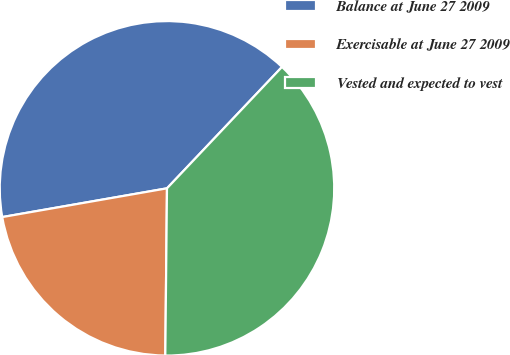Convert chart to OTSL. <chart><loc_0><loc_0><loc_500><loc_500><pie_chart><fcel>Balance at June 27 2009<fcel>Exercisable at June 27 2009<fcel>Vested and expected to vest<nl><fcel>39.82%<fcel>22.09%<fcel>38.09%<nl></chart> 